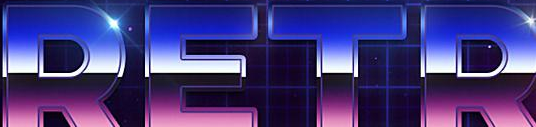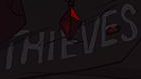What words can you see in these images in sequence, separated by a semicolon? RETR; THIEVES 